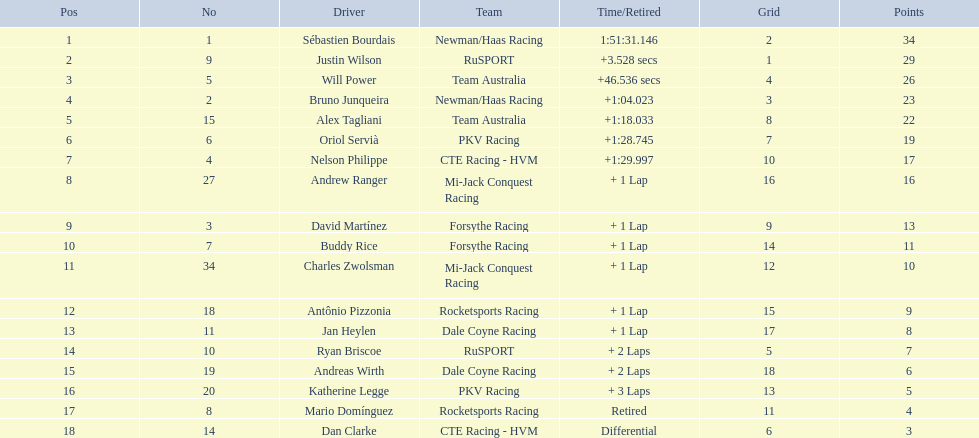Which drivers scored at least 10 points? Sébastien Bourdais, Justin Wilson, Will Power, Bruno Junqueira, Alex Tagliani, Oriol Servià, Nelson Philippe, Andrew Ranger, David Martínez, Buddy Rice, Charles Zwolsman. Of those drivers, which ones scored at least 20 points? Sébastien Bourdais, Justin Wilson, Will Power, Bruno Junqueira, Alex Tagliani. Of those 5, which driver scored the most points? Sébastien Bourdais. 